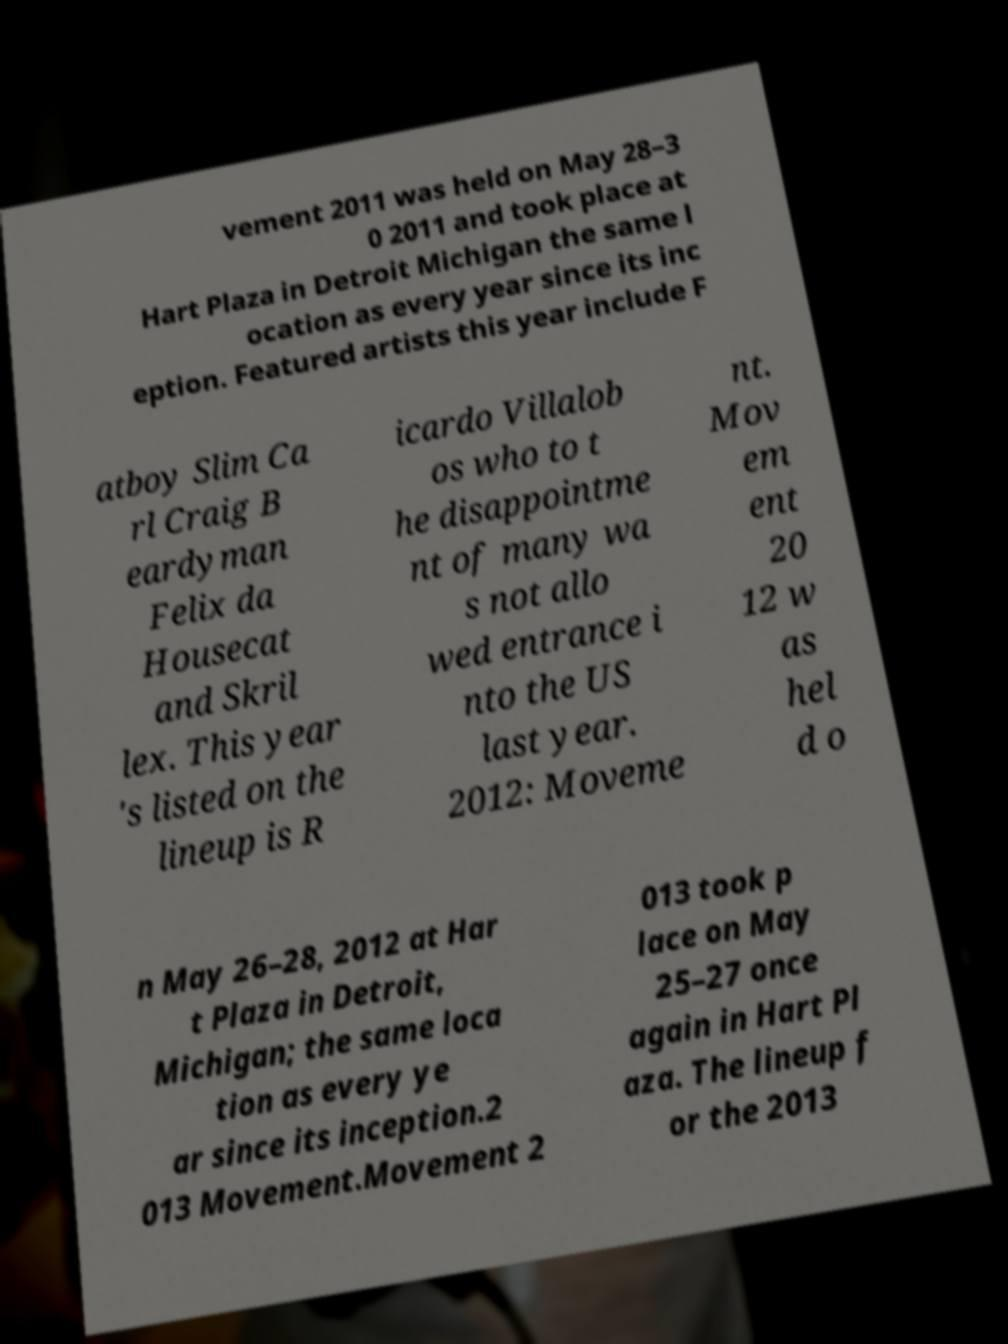Could you extract and type out the text from this image? vement 2011 was held on May 28–3 0 2011 and took place at Hart Plaza in Detroit Michigan the same l ocation as every year since its inc eption. Featured artists this year include F atboy Slim Ca rl Craig B eardyman Felix da Housecat and Skril lex. This year 's listed on the lineup is R icardo Villalob os who to t he disappointme nt of many wa s not allo wed entrance i nto the US last year. 2012: Moveme nt. Mov em ent 20 12 w as hel d o n May 26–28, 2012 at Har t Plaza in Detroit, Michigan; the same loca tion as every ye ar since its inception.2 013 Movement.Movement 2 013 took p lace on May 25–27 once again in Hart Pl aza. The lineup f or the 2013 